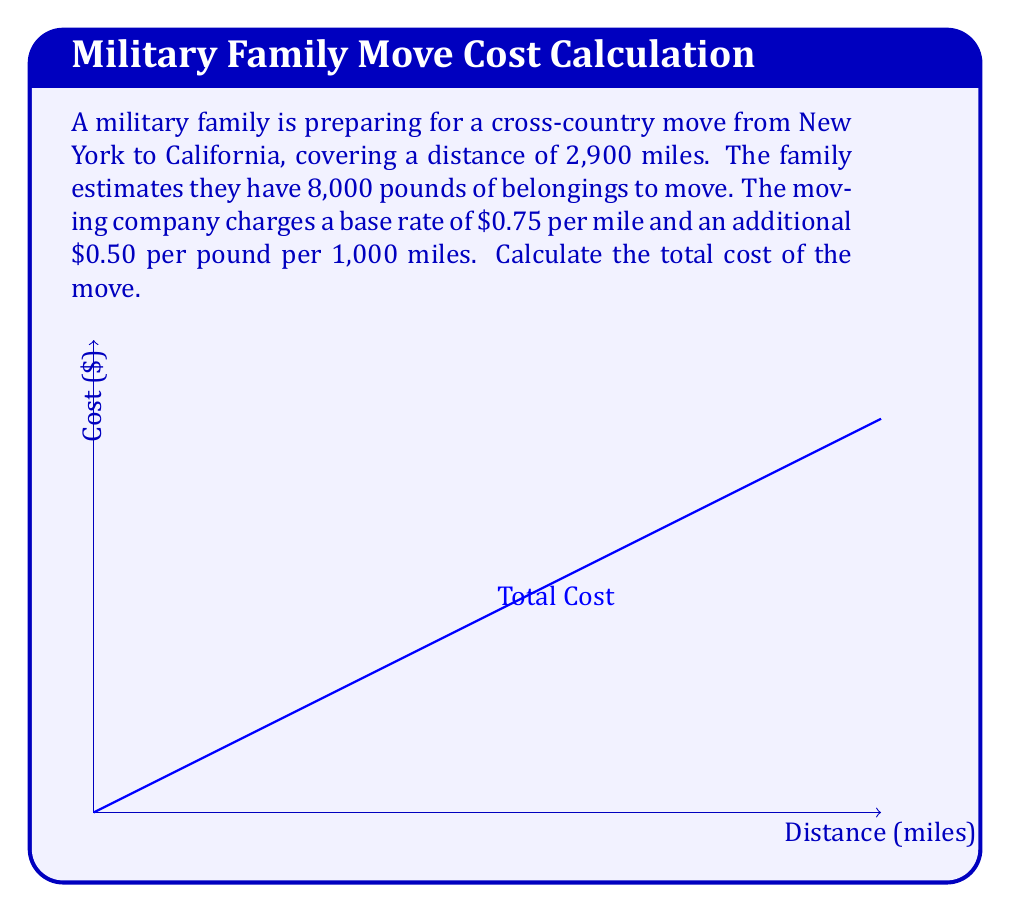Solve this math problem. Let's break this problem down step-by-step:

1) First, calculate the base cost for the distance:
   Base cost = $0.75 \times 2,900$ miles
   $$\text{Base cost} = $2,175$$

2) Next, calculate the additional cost for the weight:
   - The rate is $0.50 per pound per 1,000 miles
   - We need to adjust this for 2,900 miles
   $$\text{Adjusted rate} = $0.50 \times \frac{2,900}{1,000} = $1.45 \text{ per pound}$$

3) Now calculate the weight cost:
   $$\text{Weight cost} = $1.45 \times 8,000 \text{ pounds} = $11,600$$

4) Finally, sum up the total cost:
   $$\text{Total cost} = \text{Base cost} + \text{Weight cost}$$
   $$\text{Total cost} = $2,175 + $11,600 = $13,775$$

Therefore, the total cost of the move is $13,775.
Answer: $13,775 